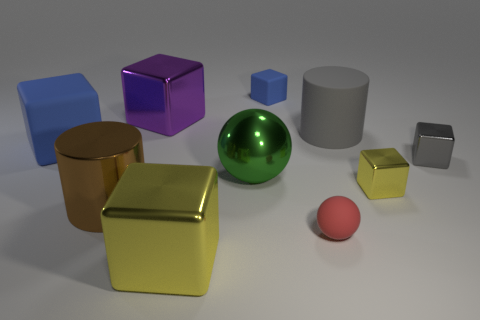The small metallic object that is the same color as the rubber cylinder is what shape?
Your response must be concise. Cube. Is the shape of the big green thing the same as the small yellow object?
Provide a succinct answer. No. What is the shape of the blue rubber thing that is behind the large matte block?
Keep it short and to the point. Cube. How many tiny yellow metallic things have the same shape as the tiny gray thing?
Your response must be concise. 1. What size is the yellow shiny block that is to the right of the cylinder that is behind the large blue rubber object?
Provide a succinct answer. Small. What number of blue objects are small matte objects or small matte cubes?
Make the answer very short. 1. Are there fewer gray shiny cubes that are in front of the small red sphere than gray cubes that are in front of the green thing?
Keep it short and to the point. No. Does the gray cylinder have the same size as the blue object that is behind the big rubber cylinder?
Offer a very short reply. No. How many yellow shiny objects have the same size as the brown shiny thing?
Keep it short and to the point. 1. What number of small objects are gray things or red matte balls?
Provide a short and direct response. 2. 